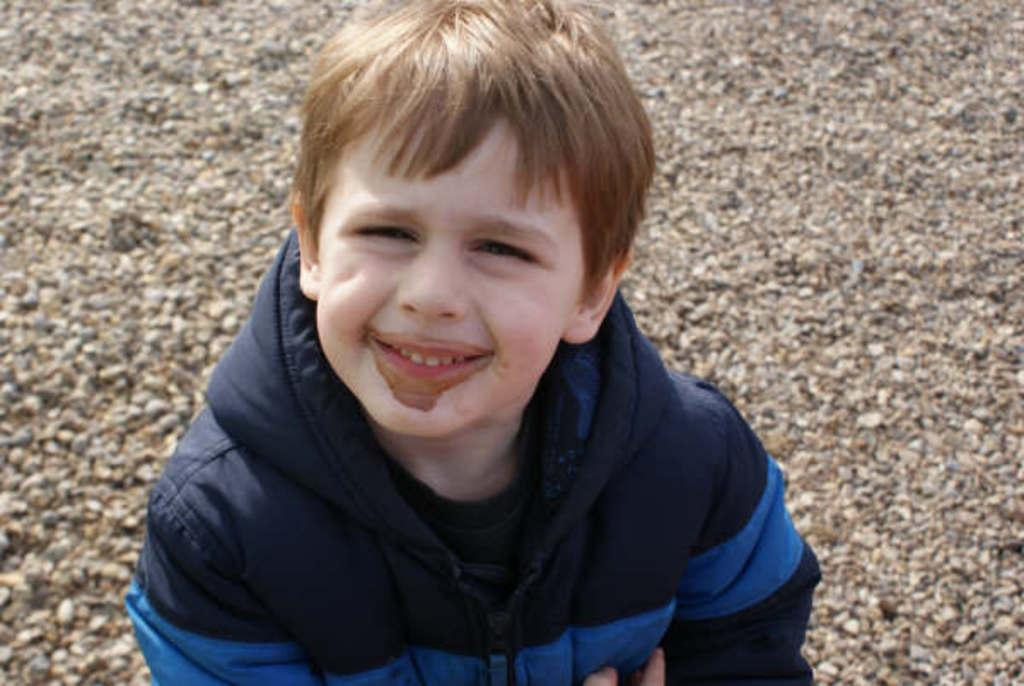What is the main subject of the image? There is a boy in the center of the image. What is the boy wearing? The boy is wearing a jacket. What can be seen at the bottom of the image? There are stones at the bottom of the image. What type of trousers is the boy wearing in the image? The provided facts do not mention the type of trousers the boy is wearing, so we cannot answer this question definitively. --- Facts: 1. There is a car in the image. 2. The car is red. 3. The car has four wheels. 4. There are people standing near the car. 5. The people are holding bags. Absurd Topics: parrot, bicycle, ocean Conversation: What is the main subject of the image? The main subject of the image is a car. What color is the car? The car is red. How many wheels does the car have? The car has four wheels. What are the people near the car doing? The people standing near the car are holding bags. Reasoning: Let's think step by step in order to produce the conversation. We start by identifying the main subject of the image, which is the car. Then, we describe the color and number of wheels of the car. Finally, we mention the people near the car and what they are doing, which is holding bags. Absurd Question/Answer: Can you see a parrot sitting on the car's roof in the image? No, there is no parrot present in the image. Is the car parked near the ocean in the image? The provided facts do not mention the location of the car or any ocean, so we cannot answer this question definitively. 